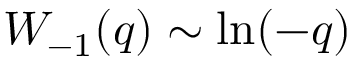Convert formula to latex. <formula><loc_0><loc_0><loc_500><loc_500>W _ { - 1 } ( q ) \sim \ln ( - q )</formula> 